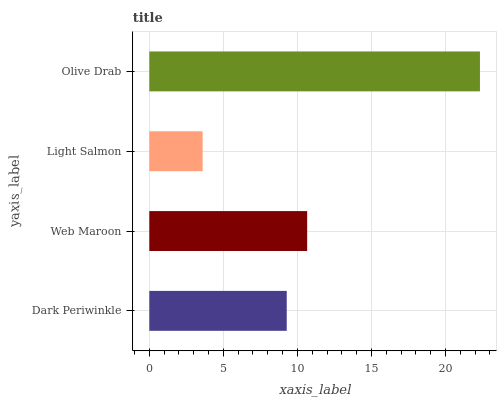Is Light Salmon the minimum?
Answer yes or no. Yes. Is Olive Drab the maximum?
Answer yes or no. Yes. Is Web Maroon the minimum?
Answer yes or no. No. Is Web Maroon the maximum?
Answer yes or no. No. Is Web Maroon greater than Dark Periwinkle?
Answer yes or no. Yes. Is Dark Periwinkle less than Web Maroon?
Answer yes or no. Yes. Is Dark Periwinkle greater than Web Maroon?
Answer yes or no. No. Is Web Maroon less than Dark Periwinkle?
Answer yes or no. No. Is Web Maroon the high median?
Answer yes or no. Yes. Is Dark Periwinkle the low median?
Answer yes or no. Yes. Is Light Salmon the high median?
Answer yes or no. No. Is Olive Drab the low median?
Answer yes or no. No. 